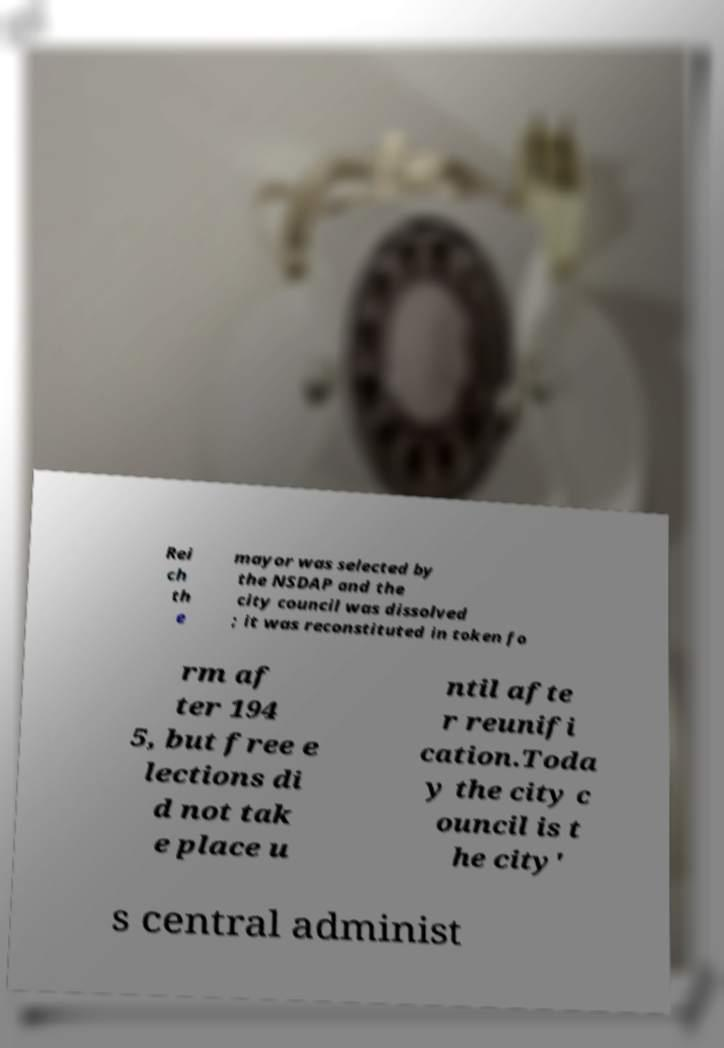Can you accurately transcribe the text from the provided image for me? Rei ch th e mayor was selected by the NSDAP and the city council was dissolved ; it was reconstituted in token fo rm af ter 194 5, but free e lections di d not tak e place u ntil afte r reunifi cation.Toda y the city c ouncil is t he city' s central administ 